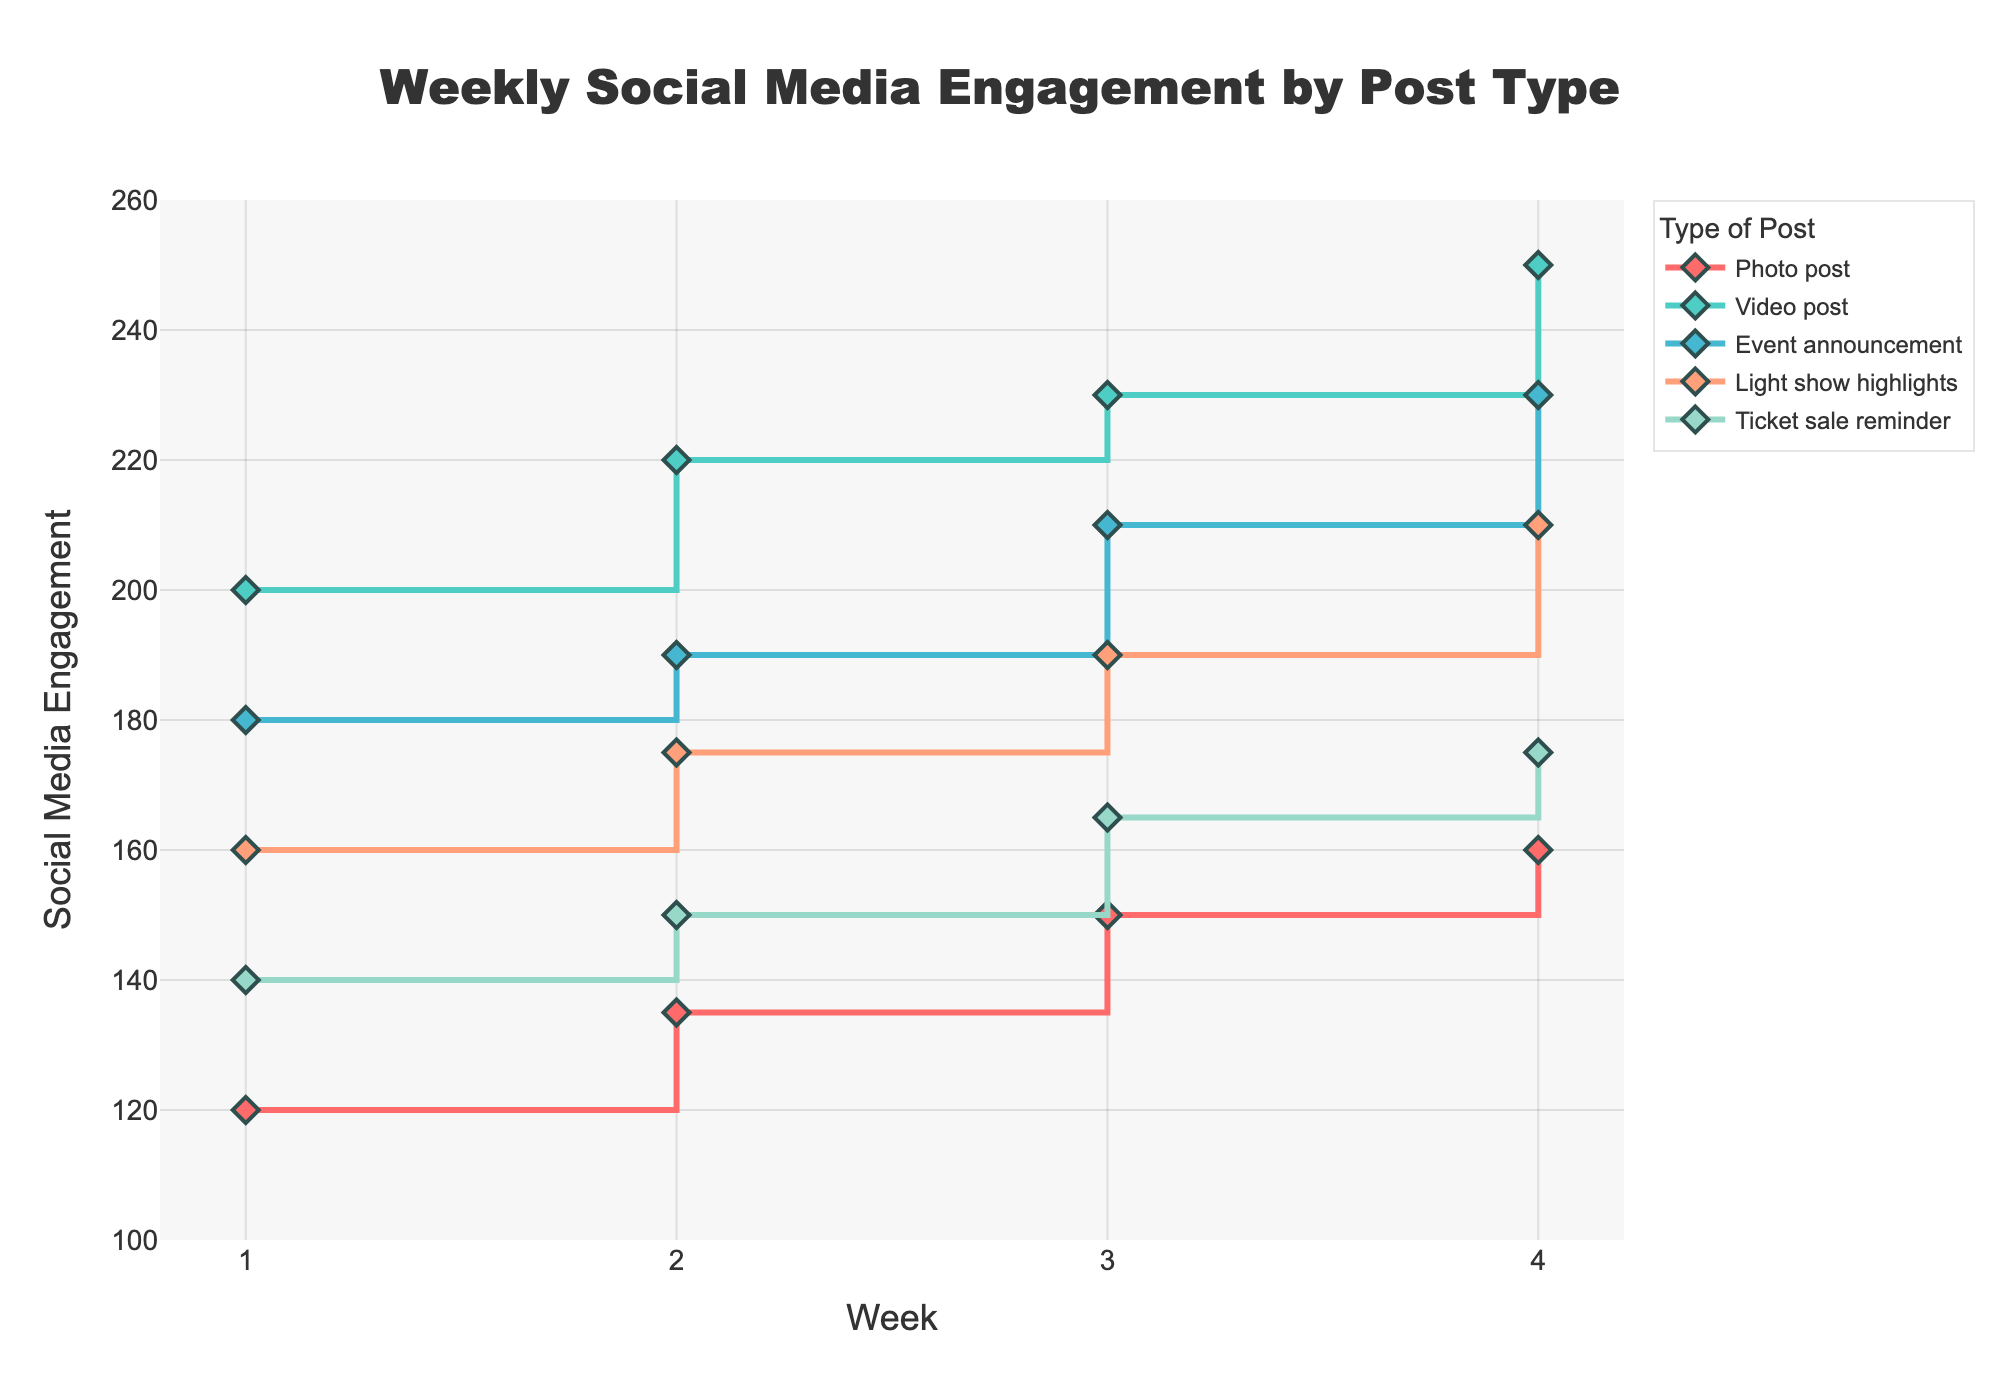What is the title of the plot? The title of the plot is displayed at the top of the figure. It is written in a large, bold font. The text reads "Weekly Social Media Engagement by Post Type".
Answer: Weekly Social Media Engagement by Post Type What does the x-axis represent? The x-axis is labeled "Week", which indicates the chronological week's progression from 1 to 4 shown along the horizontal axis.
Answer: Week How many types of posts are represented in the plot? Each line in the plot represents a different type of post. There are five lines in total; hence, five different types of posts are represented.
Answer: 5 Which type of post had the highest engagement in Week 1? By observing the markers at Week 1 for each line, the highest point is for the "Video post" which begins at 200 social media engagements.
Answer: Video post Which type of post had the lowest engagement in Week 4? We need to look at the markers at Week 4 for each line. The lowest point is for the "Photo post" with 160 social media engagements.
Answer: Photo post What is the difference in social media engagement between "Event announcement" and "Light show highlights" in Week 3? Looking at the markers for both types of posts at Week 3, "Event announcement" has 210 engagements and "Light show highlights" has 190 engagements. Subtract the two values: 210 - 190.
Answer: 20 Did the "Ticket sale reminder" engagement increase, decrease, or stay the same from Week 2 to Week 3? By comparing the values at Week 2 and Week 3 for the "Ticket sale reminder" line, we see that it increased from 150 to 165 social media engagements.
Answer: Increased How does the Week 4 engagement of "Light show highlights" compare with "Event announcement"? For Week 4, "Light show highlights" has 210 engagements, while "Event announcement" has 230. Comparing these two values, the engagement for "Light show highlights" is lower.
Answer: Lower What is the average social media engagement for "Photo post" across all weeks? The engagements for "Photo post" across the four weeks are 120, 135, 150, and 160. Summing these values (120 + 135 + 150 + 160) gives 565. Dividing by the number of weeks (4) gives the average: 565 / 4.
Answer: 141.25 Which type of post shows a consistent increase in engagements over time? Observing all the lines, we see that "Video post" shows a consistent increase from Week 1 to Week 4, moving from 200 to 220 to 230 to 250 engagements.
Answer: Video post 